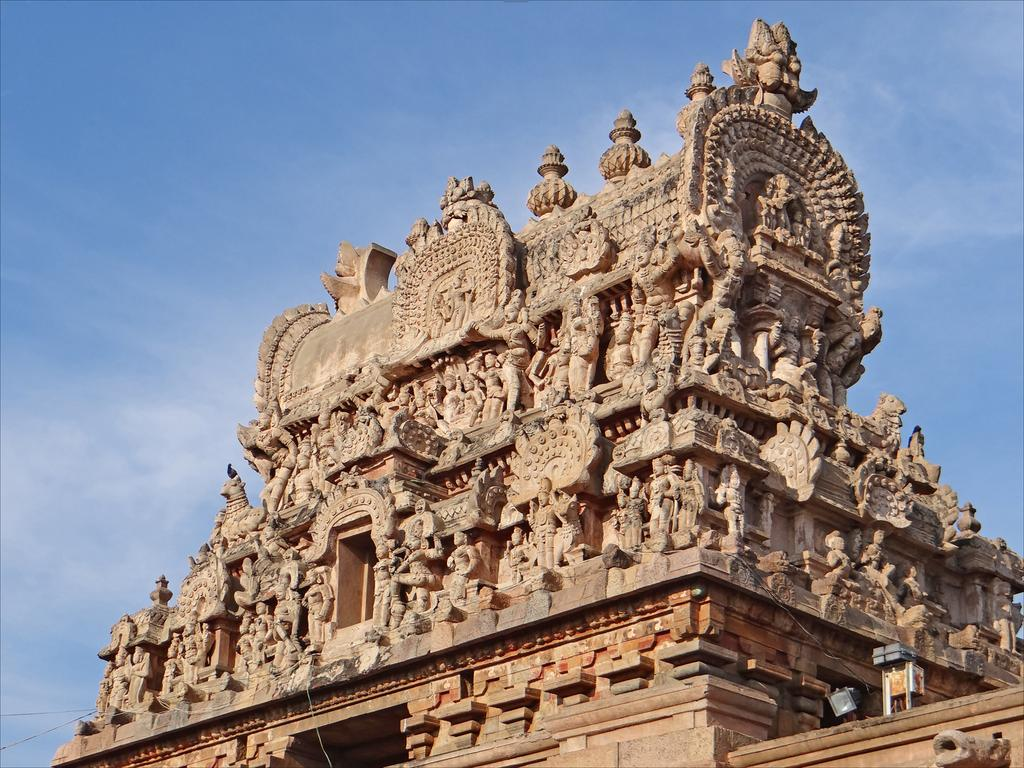What type of structure is in the image? There is a temple in the image. What can be found on the temple? The temple has sculptures. What can be seen in the background of the image? There is sky visible in the background of the image. What type of pollution can be seen around the temple in the image? There is no pollution visible in the image; it only shows the temple and the sky. What type of apparel are the sculptures wearing in the image? The provided facts do not mention any apparel worn by the sculptures, so we cannot answer this question. 